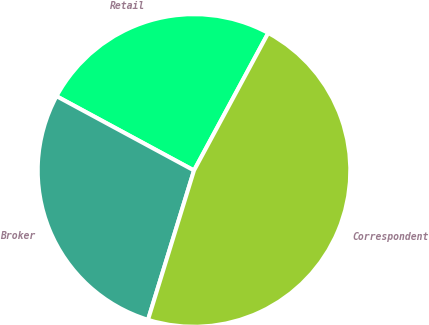Convert chart. <chart><loc_0><loc_0><loc_500><loc_500><pie_chart><fcel>Retail<fcel>Broker<fcel>Correspondent<nl><fcel>25.0%<fcel>28.13%<fcel>46.88%<nl></chart> 